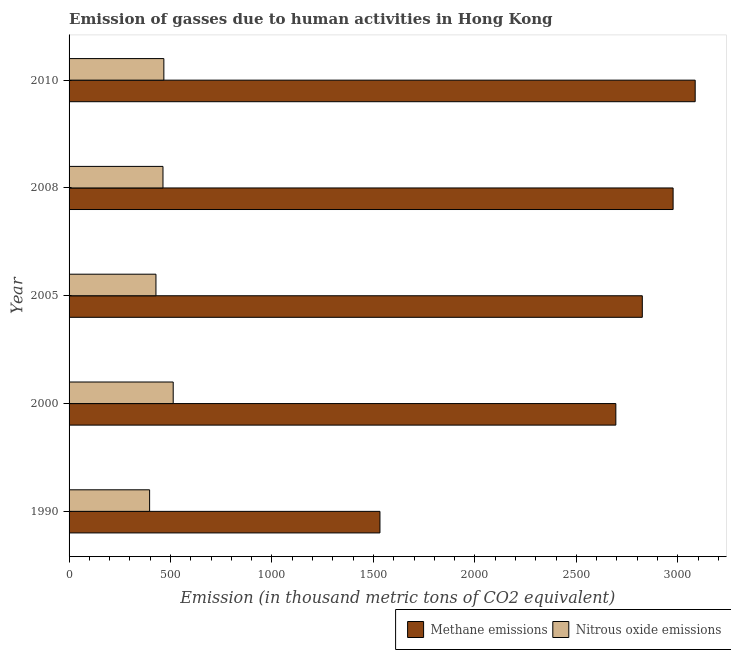How many groups of bars are there?
Keep it short and to the point. 5. Are the number of bars on each tick of the Y-axis equal?
Provide a short and direct response. Yes. How many bars are there on the 3rd tick from the bottom?
Your answer should be very brief. 2. In how many cases, is the number of bars for a given year not equal to the number of legend labels?
Provide a succinct answer. 0. What is the amount of nitrous oxide emissions in 2000?
Your answer should be compact. 513.2. Across all years, what is the maximum amount of nitrous oxide emissions?
Ensure brevity in your answer.  513.2. Across all years, what is the minimum amount of nitrous oxide emissions?
Your response must be concise. 396.9. In which year was the amount of nitrous oxide emissions maximum?
Provide a short and direct response. 2000. What is the total amount of nitrous oxide emissions in the graph?
Your answer should be compact. 2268.2. What is the difference between the amount of nitrous oxide emissions in 1990 and that in 2000?
Provide a succinct answer. -116.3. What is the difference between the amount of methane emissions in 2000 and the amount of nitrous oxide emissions in 2005?
Your answer should be compact. 2266.4. What is the average amount of methane emissions per year?
Your response must be concise. 2622.82. In the year 1990, what is the difference between the amount of methane emissions and amount of nitrous oxide emissions?
Give a very brief answer. 1135.2. In how many years, is the amount of methane emissions greater than 3100 thousand metric tons?
Offer a very short reply. 0. What is the ratio of the amount of methane emissions in 2000 to that in 2005?
Make the answer very short. 0.95. What is the difference between the highest and the second highest amount of methane emissions?
Give a very brief answer. 108.8. What is the difference between the highest and the lowest amount of nitrous oxide emissions?
Keep it short and to the point. 116.3. In how many years, is the amount of nitrous oxide emissions greater than the average amount of nitrous oxide emissions taken over all years?
Give a very brief answer. 3. Is the sum of the amount of methane emissions in 2000 and 2005 greater than the maximum amount of nitrous oxide emissions across all years?
Ensure brevity in your answer.  Yes. What does the 2nd bar from the top in 2010 represents?
Your answer should be compact. Methane emissions. What does the 1st bar from the bottom in 2005 represents?
Offer a terse response. Methane emissions. How many legend labels are there?
Your response must be concise. 2. What is the title of the graph?
Offer a very short reply. Emission of gasses due to human activities in Hong Kong. What is the label or title of the X-axis?
Offer a very short reply. Emission (in thousand metric tons of CO2 equivalent). What is the Emission (in thousand metric tons of CO2 equivalent) in Methane emissions in 1990?
Your answer should be very brief. 1532.1. What is the Emission (in thousand metric tons of CO2 equivalent) of Nitrous oxide emissions in 1990?
Your response must be concise. 396.9. What is the Emission (in thousand metric tons of CO2 equivalent) in Methane emissions in 2000?
Your response must be concise. 2694.6. What is the Emission (in thousand metric tons of CO2 equivalent) of Nitrous oxide emissions in 2000?
Keep it short and to the point. 513.2. What is the Emission (in thousand metric tons of CO2 equivalent) in Methane emissions in 2005?
Give a very brief answer. 2825. What is the Emission (in thousand metric tons of CO2 equivalent) of Nitrous oxide emissions in 2005?
Provide a succinct answer. 428.2. What is the Emission (in thousand metric tons of CO2 equivalent) of Methane emissions in 2008?
Make the answer very short. 2976.8. What is the Emission (in thousand metric tons of CO2 equivalent) in Nitrous oxide emissions in 2008?
Offer a terse response. 462.8. What is the Emission (in thousand metric tons of CO2 equivalent) in Methane emissions in 2010?
Your answer should be very brief. 3085.6. What is the Emission (in thousand metric tons of CO2 equivalent) in Nitrous oxide emissions in 2010?
Your answer should be very brief. 467.1. Across all years, what is the maximum Emission (in thousand metric tons of CO2 equivalent) in Methane emissions?
Offer a terse response. 3085.6. Across all years, what is the maximum Emission (in thousand metric tons of CO2 equivalent) of Nitrous oxide emissions?
Give a very brief answer. 513.2. Across all years, what is the minimum Emission (in thousand metric tons of CO2 equivalent) in Methane emissions?
Give a very brief answer. 1532.1. Across all years, what is the minimum Emission (in thousand metric tons of CO2 equivalent) in Nitrous oxide emissions?
Ensure brevity in your answer.  396.9. What is the total Emission (in thousand metric tons of CO2 equivalent) of Methane emissions in the graph?
Provide a short and direct response. 1.31e+04. What is the total Emission (in thousand metric tons of CO2 equivalent) of Nitrous oxide emissions in the graph?
Ensure brevity in your answer.  2268.2. What is the difference between the Emission (in thousand metric tons of CO2 equivalent) of Methane emissions in 1990 and that in 2000?
Provide a succinct answer. -1162.5. What is the difference between the Emission (in thousand metric tons of CO2 equivalent) of Nitrous oxide emissions in 1990 and that in 2000?
Offer a terse response. -116.3. What is the difference between the Emission (in thousand metric tons of CO2 equivalent) of Methane emissions in 1990 and that in 2005?
Your response must be concise. -1292.9. What is the difference between the Emission (in thousand metric tons of CO2 equivalent) in Nitrous oxide emissions in 1990 and that in 2005?
Provide a succinct answer. -31.3. What is the difference between the Emission (in thousand metric tons of CO2 equivalent) in Methane emissions in 1990 and that in 2008?
Your answer should be very brief. -1444.7. What is the difference between the Emission (in thousand metric tons of CO2 equivalent) in Nitrous oxide emissions in 1990 and that in 2008?
Provide a short and direct response. -65.9. What is the difference between the Emission (in thousand metric tons of CO2 equivalent) of Methane emissions in 1990 and that in 2010?
Give a very brief answer. -1553.5. What is the difference between the Emission (in thousand metric tons of CO2 equivalent) in Nitrous oxide emissions in 1990 and that in 2010?
Make the answer very short. -70.2. What is the difference between the Emission (in thousand metric tons of CO2 equivalent) in Methane emissions in 2000 and that in 2005?
Give a very brief answer. -130.4. What is the difference between the Emission (in thousand metric tons of CO2 equivalent) in Methane emissions in 2000 and that in 2008?
Provide a short and direct response. -282.2. What is the difference between the Emission (in thousand metric tons of CO2 equivalent) in Nitrous oxide emissions in 2000 and that in 2008?
Your answer should be very brief. 50.4. What is the difference between the Emission (in thousand metric tons of CO2 equivalent) in Methane emissions in 2000 and that in 2010?
Offer a very short reply. -391. What is the difference between the Emission (in thousand metric tons of CO2 equivalent) of Nitrous oxide emissions in 2000 and that in 2010?
Offer a terse response. 46.1. What is the difference between the Emission (in thousand metric tons of CO2 equivalent) in Methane emissions in 2005 and that in 2008?
Keep it short and to the point. -151.8. What is the difference between the Emission (in thousand metric tons of CO2 equivalent) of Nitrous oxide emissions in 2005 and that in 2008?
Provide a short and direct response. -34.6. What is the difference between the Emission (in thousand metric tons of CO2 equivalent) of Methane emissions in 2005 and that in 2010?
Your answer should be compact. -260.6. What is the difference between the Emission (in thousand metric tons of CO2 equivalent) in Nitrous oxide emissions in 2005 and that in 2010?
Give a very brief answer. -38.9. What is the difference between the Emission (in thousand metric tons of CO2 equivalent) of Methane emissions in 2008 and that in 2010?
Provide a succinct answer. -108.8. What is the difference between the Emission (in thousand metric tons of CO2 equivalent) of Nitrous oxide emissions in 2008 and that in 2010?
Keep it short and to the point. -4.3. What is the difference between the Emission (in thousand metric tons of CO2 equivalent) of Methane emissions in 1990 and the Emission (in thousand metric tons of CO2 equivalent) of Nitrous oxide emissions in 2000?
Ensure brevity in your answer.  1018.9. What is the difference between the Emission (in thousand metric tons of CO2 equivalent) of Methane emissions in 1990 and the Emission (in thousand metric tons of CO2 equivalent) of Nitrous oxide emissions in 2005?
Your answer should be compact. 1103.9. What is the difference between the Emission (in thousand metric tons of CO2 equivalent) of Methane emissions in 1990 and the Emission (in thousand metric tons of CO2 equivalent) of Nitrous oxide emissions in 2008?
Your response must be concise. 1069.3. What is the difference between the Emission (in thousand metric tons of CO2 equivalent) in Methane emissions in 1990 and the Emission (in thousand metric tons of CO2 equivalent) in Nitrous oxide emissions in 2010?
Provide a succinct answer. 1065. What is the difference between the Emission (in thousand metric tons of CO2 equivalent) of Methane emissions in 2000 and the Emission (in thousand metric tons of CO2 equivalent) of Nitrous oxide emissions in 2005?
Ensure brevity in your answer.  2266.4. What is the difference between the Emission (in thousand metric tons of CO2 equivalent) in Methane emissions in 2000 and the Emission (in thousand metric tons of CO2 equivalent) in Nitrous oxide emissions in 2008?
Make the answer very short. 2231.8. What is the difference between the Emission (in thousand metric tons of CO2 equivalent) of Methane emissions in 2000 and the Emission (in thousand metric tons of CO2 equivalent) of Nitrous oxide emissions in 2010?
Make the answer very short. 2227.5. What is the difference between the Emission (in thousand metric tons of CO2 equivalent) in Methane emissions in 2005 and the Emission (in thousand metric tons of CO2 equivalent) in Nitrous oxide emissions in 2008?
Make the answer very short. 2362.2. What is the difference between the Emission (in thousand metric tons of CO2 equivalent) in Methane emissions in 2005 and the Emission (in thousand metric tons of CO2 equivalent) in Nitrous oxide emissions in 2010?
Make the answer very short. 2357.9. What is the difference between the Emission (in thousand metric tons of CO2 equivalent) in Methane emissions in 2008 and the Emission (in thousand metric tons of CO2 equivalent) in Nitrous oxide emissions in 2010?
Give a very brief answer. 2509.7. What is the average Emission (in thousand metric tons of CO2 equivalent) in Methane emissions per year?
Ensure brevity in your answer.  2622.82. What is the average Emission (in thousand metric tons of CO2 equivalent) of Nitrous oxide emissions per year?
Give a very brief answer. 453.64. In the year 1990, what is the difference between the Emission (in thousand metric tons of CO2 equivalent) of Methane emissions and Emission (in thousand metric tons of CO2 equivalent) of Nitrous oxide emissions?
Your answer should be compact. 1135.2. In the year 2000, what is the difference between the Emission (in thousand metric tons of CO2 equivalent) in Methane emissions and Emission (in thousand metric tons of CO2 equivalent) in Nitrous oxide emissions?
Your answer should be very brief. 2181.4. In the year 2005, what is the difference between the Emission (in thousand metric tons of CO2 equivalent) of Methane emissions and Emission (in thousand metric tons of CO2 equivalent) of Nitrous oxide emissions?
Provide a short and direct response. 2396.8. In the year 2008, what is the difference between the Emission (in thousand metric tons of CO2 equivalent) of Methane emissions and Emission (in thousand metric tons of CO2 equivalent) of Nitrous oxide emissions?
Make the answer very short. 2514. In the year 2010, what is the difference between the Emission (in thousand metric tons of CO2 equivalent) in Methane emissions and Emission (in thousand metric tons of CO2 equivalent) in Nitrous oxide emissions?
Offer a very short reply. 2618.5. What is the ratio of the Emission (in thousand metric tons of CO2 equivalent) in Methane emissions in 1990 to that in 2000?
Provide a short and direct response. 0.57. What is the ratio of the Emission (in thousand metric tons of CO2 equivalent) of Nitrous oxide emissions in 1990 to that in 2000?
Keep it short and to the point. 0.77. What is the ratio of the Emission (in thousand metric tons of CO2 equivalent) in Methane emissions in 1990 to that in 2005?
Your answer should be compact. 0.54. What is the ratio of the Emission (in thousand metric tons of CO2 equivalent) in Nitrous oxide emissions in 1990 to that in 2005?
Keep it short and to the point. 0.93. What is the ratio of the Emission (in thousand metric tons of CO2 equivalent) in Methane emissions in 1990 to that in 2008?
Provide a short and direct response. 0.51. What is the ratio of the Emission (in thousand metric tons of CO2 equivalent) of Nitrous oxide emissions in 1990 to that in 2008?
Provide a succinct answer. 0.86. What is the ratio of the Emission (in thousand metric tons of CO2 equivalent) in Methane emissions in 1990 to that in 2010?
Keep it short and to the point. 0.5. What is the ratio of the Emission (in thousand metric tons of CO2 equivalent) in Nitrous oxide emissions in 1990 to that in 2010?
Ensure brevity in your answer.  0.85. What is the ratio of the Emission (in thousand metric tons of CO2 equivalent) of Methane emissions in 2000 to that in 2005?
Keep it short and to the point. 0.95. What is the ratio of the Emission (in thousand metric tons of CO2 equivalent) of Nitrous oxide emissions in 2000 to that in 2005?
Provide a short and direct response. 1.2. What is the ratio of the Emission (in thousand metric tons of CO2 equivalent) of Methane emissions in 2000 to that in 2008?
Ensure brevity in your answer.  0.91. What is the ratio of the Emission (in thousand metric tons of CO2 equivalent) of Nitrous oxide emissions in 2000 to that in 2008?
Give a very brief answer. 1.11. What is the ratio of the Emission (in thousand metric tons of CO2 equivalent) of Methane emissions in 2000 to that in 2010?
Make the answer very short. 0.87. What is the ratio of the Emission (in thousand metric tons of CO2 equivalent) in Nitrous oxide emissions in 2000 to that in 2010?
Ensure brevity in your answer.  1.1. What is the ratio of the Emission (in thousand metric tons of CO2 equivalent) of Methane emissions in 2005 to that in 2008?
Offer a terse response. 0.95. What is the ratio of the Emission (in thousand metric tons of CO2 equivalent) in Nitrous oxide emissions in 2005 to that in 2008?
Offer a terse response. 0.93. What is the ratio of the Emission (in thousand metric tons of CO2 equivalent) in Methane emissions in 2005 to that in 2010?
Ensure brevity in your answer.  0.92. What is the ratio of the Emission (in thousand metric tons of CO2 equivalent) of Methane emissions in 2008 to that in 2010?
Give a very brief answer. 0.96. What is the ratio of the Emission (in thousand metric tons of CO2 equivalent) in Nitrous oxide emissions in 2008 to that in 2010?
Ensure brevity in your answer.  0.99. What is the difference between the highest and the second highest Emission (in thousand metric tons of CO2 equivalent) in Methane emissions?
Your answer should be very brief. 108.8. What is the difference between the highest and the second highest Emission (in thousand metric tons of CO2 equivalent) in Nitrous oxide emissions?
Ensure brevity in your answer.  46.1. What is the difference between the highest and the lowest Emission (in thousand metric tons of CO2 equivalent) of Methane emissions?
Your answer should be very brief. 1553.5. What is the difference between the highest and the lowest Emission (in thousand metric tons of CO2 equivalent) of Nitrous oxide emissions?
Provide a succinct answer. 116.3. 